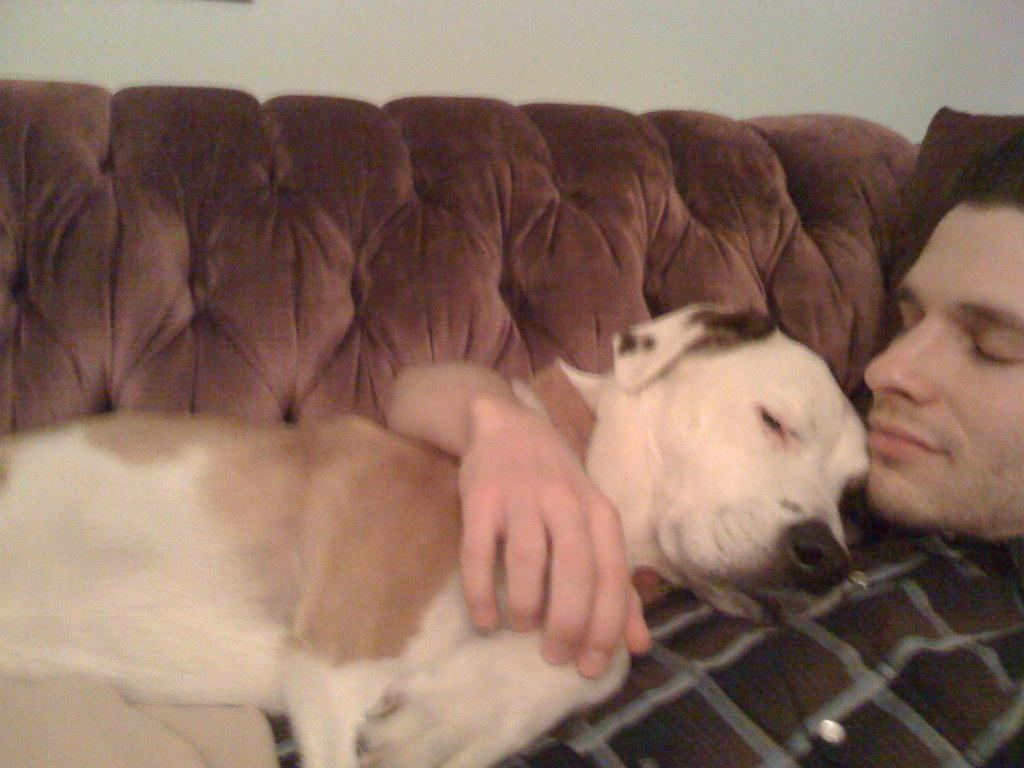Who is present in the image? There is a man in the image. What other living creature is present in the image? There is a dog in the image. What are the man and the dog doing in the image? Both the man and the dog are sleeping on the sofa. What can be seen in the background of the image? There is a wall in the background of the image. How many dimes are scattered on the floor in the image? There are no dimes present in the image. What type of laborer is depicted in the image? There is no laborer depicted in the image; it features a man and a dog sleeping on a sofa. 